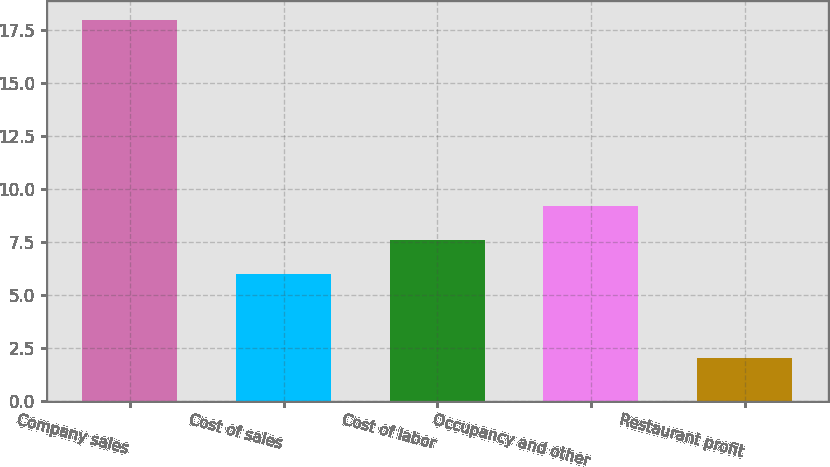<chart> <loc_0><loc_0><loc_500><loc_500><bar_chart><fcel>Company sales<fcel>Cost of sales<fcel>Cost of labor<fcel>Occupancy and other<fcel>Restaurant profit<nl><fcel>18<fcel>6<fcel>7.6<fcel>9.2<fcel>2<nl></chart> 